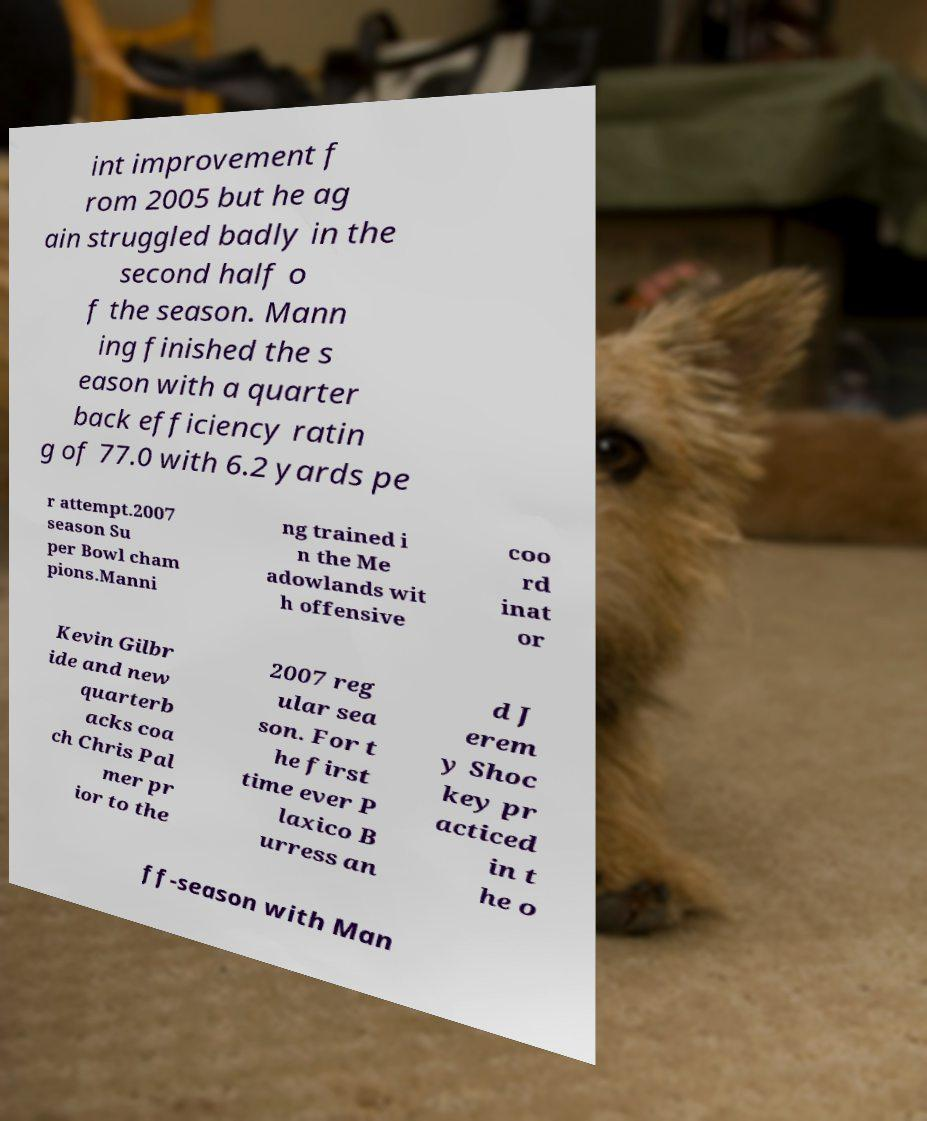Please read and relay the text visible in this image. What does it say? int improvement f rom 2005 but he ag ain struggled badly in the second half o f the season. Mann ing finished the s eason with a quarter back efficiency ratin g of 77.0 with 6.2 yards pe r attempt.2007 season Su per Bowl cham pions.Manni ng trained i n the Me adowlands wit h offensive coo rd inat or Kevin Gilbr ide and new quarterb acks coa ch Chris Pal mer pr ior to the 2007 reg ular sea son. For t he first time ever P laxico B urress an d J erem y Shoc key pr acticed in t he o ff-season with Man 